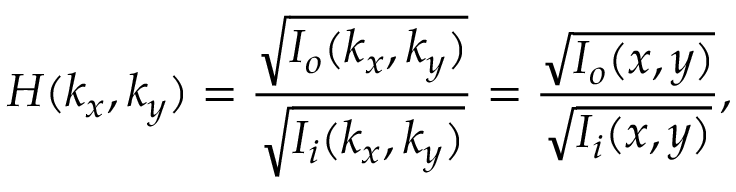<formula> <loc_0><loc_0><loc_500><loc_500>H ( k _ { x } , k _ { y } ) = \frac { \sqrt { I _ { o } ( k _ { x } , k _ { y } ) } } { \sqrt { I _ { i } ( k _ { x } , k _ { y } ) } } = \frac { \sqrt { I _ { o } ( x , y ) } } { \sqrt { I _ { i } ( x , y ) } } ,</formula> 